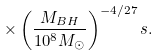Convert formula to latex. <formula><loc_0><loc_0><loc_500><loc_500>\times \left ( \frac { M _ { B H } } { 1 0 ^ { 8 } M _ { \odot } } \right ) ^ { - 4 / 2 7 } s .</formula> 